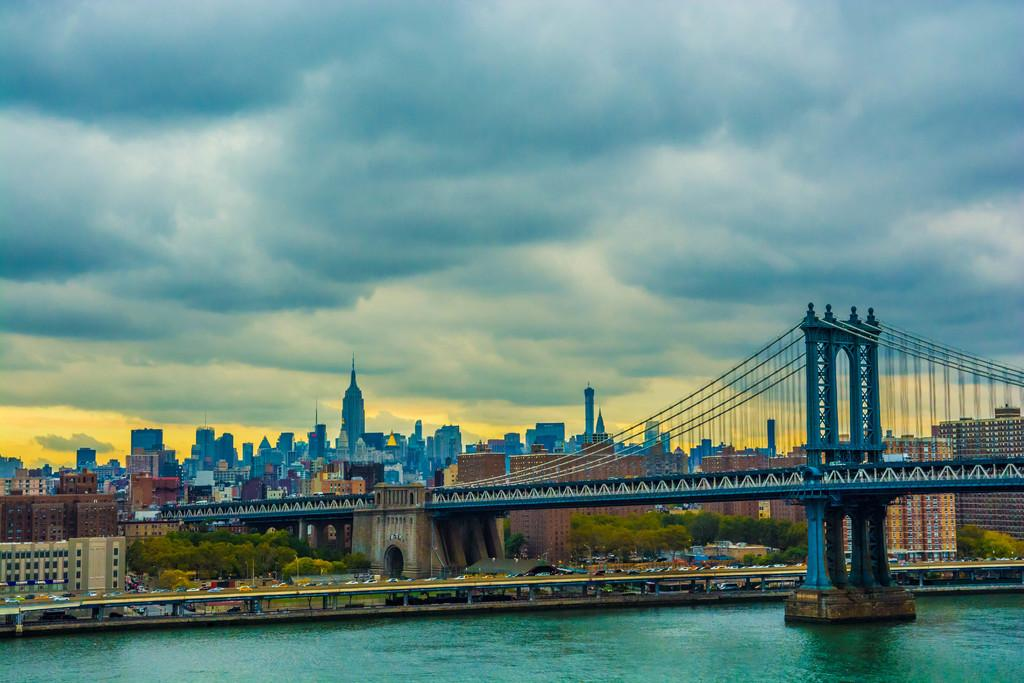What structure can be seen in the picture? There is a bridge in the picture. What natural element is visible in the picture? There is water visible in the picture. What type of barrier is present in the picture? There is a fence in the picture. What type of vegetation can be seen in the picture? There are trees in the picture. What man-made structures are present in the picture? There are buildings in the picture. What can be seen in the background of the picture? The sky with clouds is visible in the background of the picture. What type of rice is being served for lunch in the picture? There is no reference to lunch or rice in the image; it features a bridge, water, a fence, trees, buildings, and a sky with clouds. 